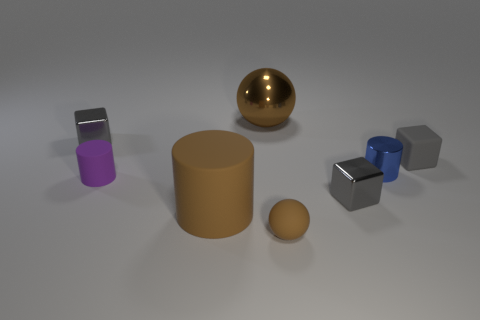There is a gray metallic cube that is on the left side of the brown metallic ball; is it the same size as the brown thing that is to the left of the brown shiny object?
Provide a succinct answer. No. How many things have the same color as the large metal sphere?
Make the answer very short. 2. How many small things are red rubber cubes or shiny blocks?
Give a very brief answer. 2. Is the material of the tiny cylinder to the right of the large ball the same as the large ball?
Offer a very short reply. Yes. There is a small cylinder on the right side of the large brown metal thing; what is its color?
Make the answer very short. Blue. Is there a yellow rubber cylinder of the same size as the metallic cylinder?
Keep it short and to the point. No. What material is the blue cylinder that is the same size as the gray rubber block?
Provide a succinct answer. Metal. There is a brown cylinder; is its size the same as the gray object that is behind the gray rubber object?
Offer a very short reply. No. There is a tiny gray block in front of the blue metallic cylinder; what is it made of?
Keep it short and to the point. Metal. Is the number of small gray objects in front of the blue metallic thing the same as the number of blue cylinders?
Provide a succinct answer. Yes. 